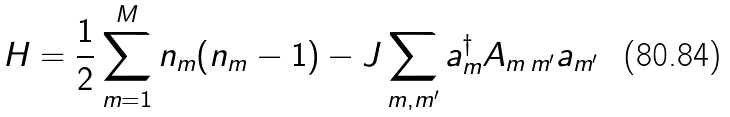Convert formula to latex. <formula><loc_0><loc_0><loc_500><loc_500>H = \frac { 1 } { 2 } \sum _ { m = 1 } ^ { M } n _ { m } ( n _ { m } - 1 ) - J \sum _ { m , m ^ { \prime } } a _ { m } ^ { \dag } A _ { m \, m ^ { \prime } } a _ { m ^ { \prime } }</formula> 